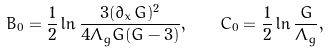Convert formula to latex. <formula><loc_0><loc_0><loc_500><loc_500>B _ { 0 } = \frac { 1 } { 2 } \ln \frac { 3 ( \partial _ { x } G ) ^ { 2 } } { 4 \Lambda _ { g } G ( G - 3 ) } , \quad C _ { 0 } = \frac { 1 } { 2 } \ln \frac { G } { \Lambda _ { g } } ,</formula> 